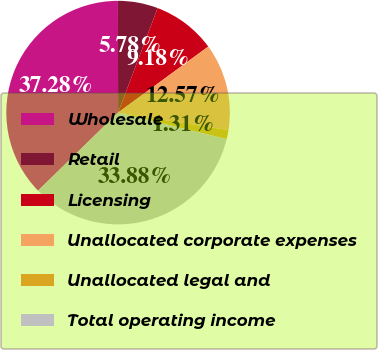Convert chart. <chart><loc_0><loc_0><loc_500><loc_500><pie_chart><fcel>Wholesale<fcel>Retail<fcel>Licensing<fcel>Unallocated corporate expenses<fcel>Unallocated legal and<fcel>Total operating income<nl><fcel>37.28%<fcel>5.78%<fcel>9.18%<fcel>12.57%<fcel>1.31%<fcel>33.88%<nl></chart> 